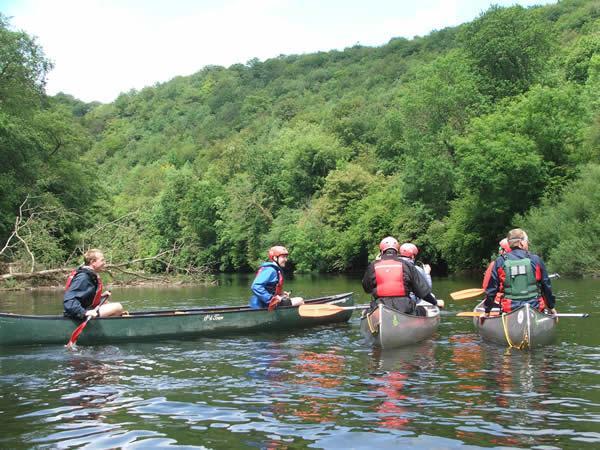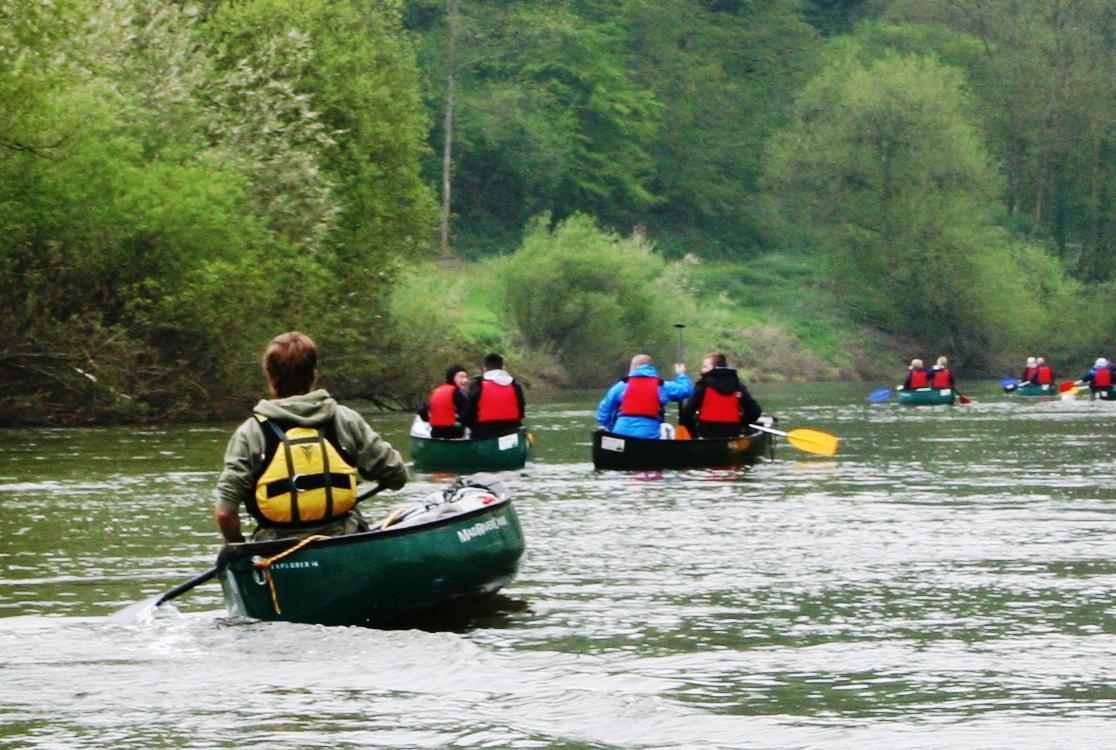The first image is the image on the left, the second image is the image on the right. Evaluate the accuracy of this statement regarding the images: "In at least one image there are a total three small boat.". Is it true? Answer yes or no. Yes. 